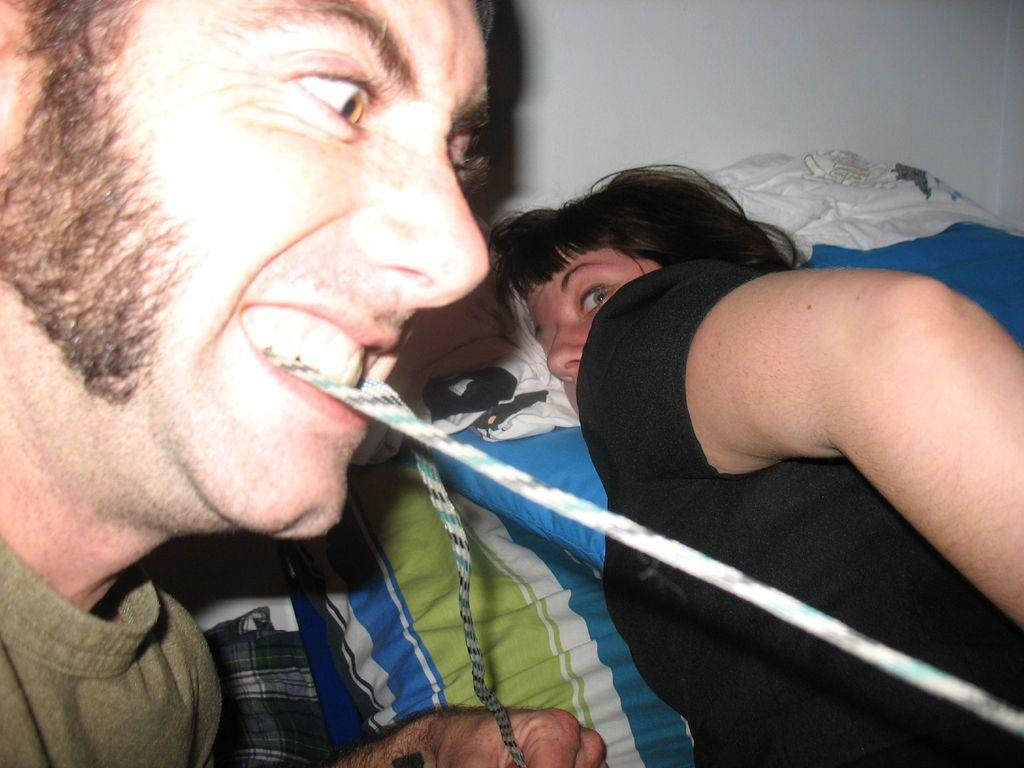What is the man doing in the image? The guy is holding a thread with his mouth in the image. Who else is present in the image? There is a woman in the image. What is the woman doing in the image? The woman is sleeping on a bed in the image. Where is the bed located in the image? The bed is in the background of the image. How many legs does the guy have in the image? The number of legs the guy has cannot be determined from the image, as it only shows his upper body. 